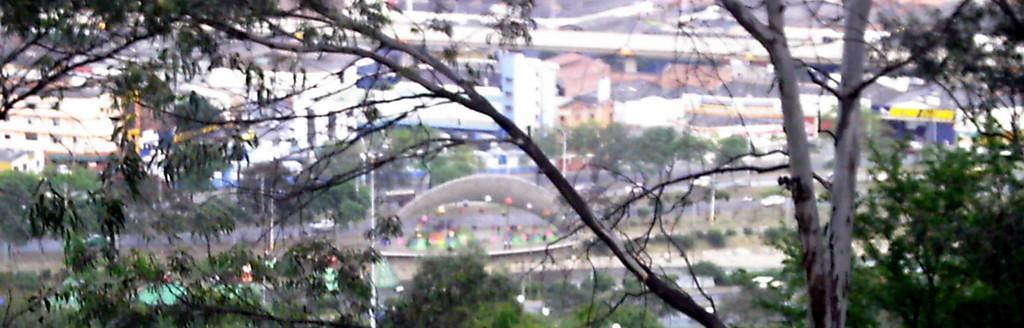In one or two sentences, can you explain what this image depicts? In the foreground of the picture there are trees. The background is blurred. In the background there are buildings, trees, poles and other objects. 